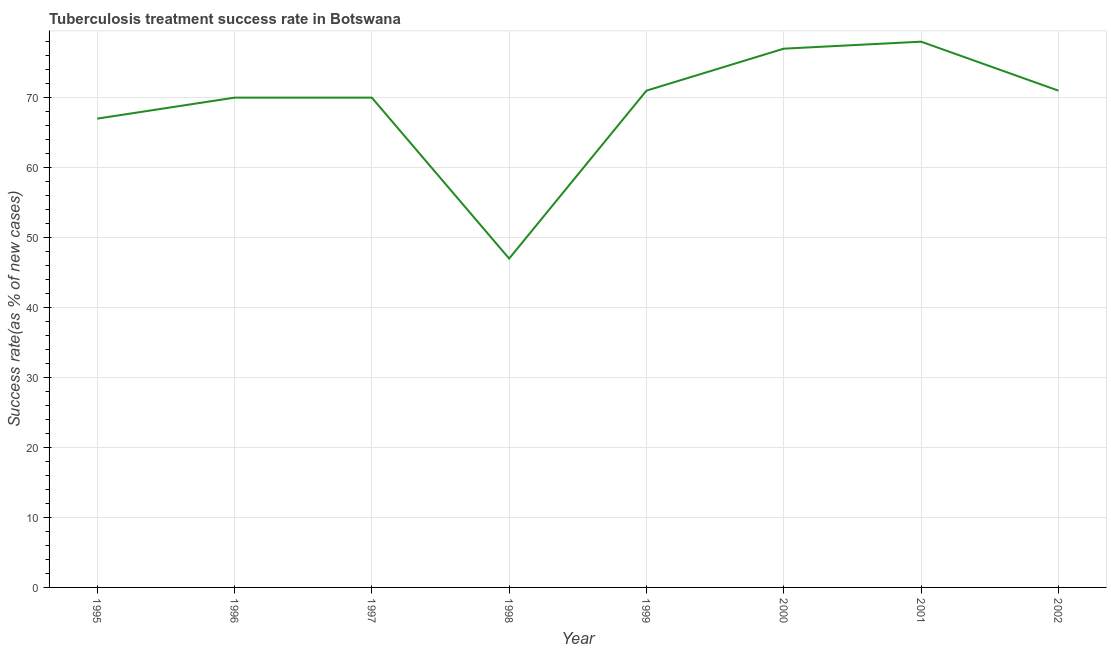What is the tuberculosis treatment success rate in 1997?
Your response must be concise. 70. Across all years, what is the maximum tuberculosis treatment success rate?
Provide a succinct answer. 78. Across all years, what is the minimum tuberculosis treatment success rate?
Make the answer very short. 47. In which year was the tuberculosis treatment success rate minimum?
Your answer should be compact. 1998. What is the sum of the tuberculosis treatment success rate?
Ensure brevity in your answer.  551. What is the difference between the tuberculosis treatment success rate in 1998 and 2000?
Keep it short and to the point. -30. What is the average tuberculosis treatment success rate per year?
Offer a terse response. 68.88. What is the median tuberculosis treatment success rate?
Offer a terse response. 70.5. In how many years, is the tuberculosis treatment success rate greater than 68 %?
Give a very brief answer. 6. What is the ratio of the tuberculosis treatment success rate in 1997 to that in 1998?
Your response must be concise. 1.49. Is the tuberculosis treatment success rate in 1999 less than that in 2001?
Give a very brief answer. Yes. What is the difference between the highest and the lowest tuberculosis treatment success rate?
Your answer should be very brief. 31. In how many years, is the tuberculosis treatment success rate greater than the average tuberculosis treatment success rate taken over all years?
Your response must be concise. 6. Does the tuberculosis treatment success rate monotonically increase over the years?
Offer a terse response. No. How many lines are there?
Offer a very short reply. 1. What is the difference between two consecutive major ticks on the Y-axis?
Keep it short and to the point. 10. Are the values on the major ticks of Y-axis written in scientific E-notation?
Your response must be concise. No. What is the title of the graph?
Your response must be concise. Tuberculosis treatment success rate in Botswana. What is the label or title of the Y-axis?
Ensure brevity in your answer.  Success rate(as % of new cases). What is the Success rate(as % of new cases) of 1995?
Make the answer very short. 67. What is the Success rate(as % of new cases) in 1996?
Give a very brief answer. 70. What is the Success rate(as % of new cases) of 1998?
Your answer should be compact. 47. What is the Success rate(as % of new cases) of 2000?
Your answer should be compact. 77. What is the Success rate(as % of new cases) in 2001?
Your response must be concise. 78. What is the Success rate(as % of new cases) of 2002?
Provide a succinct answer. 71. What is the difference between the Success rate(as % of new cases) in 1995 and 1996?
Provide a short and direct response. -3. What is the difference between the Success rate(as % of new cases) in 1995 and 1998?
Ensure brevity in your answer.  20. What is the difference between the Success rate(as % of new cases) in 1995 and 2001?
Provide a short and direct response. -11. What is the difference between the Success rate(as % of new cases) in 1996 and 1997?
Your response must be concise. 0. What is the difference between the Success rate(as % of new cases) in 1996 and 1998?
Give a very brief answer. 23. What is the difference between the Success rate(as % of new cases) in 1997 and 1998?
Your response must be concise. 23. What is the difference between the Success rate(as % of new cases) in 1997 and 2002?
Provide a short and direct response. -1. What is the difference between the Success rate(as % of new cases) in 1998 and 1999?
Your answer should be very brief. -24. What is the difference between the Success rate(as % of new cases) in 1998 and 2001?
Provide a short and direct response. -31. What is the difference between the Success rate(as % of new cases) in 2001 and 2002?
Make the answer very short. 7. What is the ratio of the Success rate(as % of new cases) in 1995 to that in 1996?
Offer a very short reply. 0.96. What is the ratio of the Success rate(as % of new cases) in 1995 to that in 1997?
Provide a short and direct response. 0.96. What is the ratio of the Success rate(as % of new cases) in 1995 to that in 1998?
Keep it short and to the point. 1.43. What is the ratio of the Success rate(as % of new cases) in 1995 to that in 1999?
Give a very brief answer. 0.94. What is the ratio of the Success rate(as % of new cases) in 1995 to that in 2000?
Your answer should be compact. 0.87. What is the ratio of the Success rate(as % of new cases) in 1995 to that in 2001?
Offer a terse response. 0.86. What is the ratio of the Success rate(as % of new cases) in 1995 to that in 2002?
Ensure brevity in your answer.  0.94. What is the ratio of the Success rate(as % of new cases) in 1996 to that in 1997?
Keep it short and to the point. 1. What is the ratio of the Success rate(as % of new cases) in 1996 to that in 1998?
Offer a very short reply. 1.49. What is the ratio of the Success rate(as % of new cases) in 1996 to that in 2000?
Give a very brief answer. 0.91. What is the ratio of the Success rate(as % of new cases) in 1996 to that in 2001?
Offer a very short reply. 0.9. What is the ratio of the Success rate(as % of new cases) in 1996 to that in 2002?
Your answer should be very brief. 0.99. What is the ratio of the Success rate(as % of new cases) in 1997 to that in 1998?
Your response must be concise. 1.49. What is the ratio of the Success rate(as % of new cases) in 1997 to that in 2000?
Your answer should be compact. 0.91. What is the ratio of the Success rate(as % of new cases) in 1997 to that in 2001?
Provide a short and direct response. 0.9. What is the ratio of the Success rate(as % of new cases) in 1998 to that in 1999?
Offer a very short reply. 0.66. What is the ratio of the Success rate(as % of new cases) in 1998 to that in 2000?
Keep it short and to the point. 0.61. What is the ratio of the Success rate(as % of new cases) in 1998 to that in 2001?
Your answer should be compact. 0.6. What is the ratio of the Success rate(as % of new cases) in 1998 to that in 2002?
Give a very brief answer. 0.66. What is the ratio of the Success rate(as % of new cases) in 1999 to that in 2000?
Your response must be concise. 0.92. What is the ratio of the Success rate(as % of new cases) in 1999 to that in 2001?
Make the answer very short. 0.91. What is the ratio of the Success rate(as % of new cases) in 1999 to that in 2002?
Provide a succinct answer. 1. What is the ratio of the Success rate(as % of new cases) in 2000 to that in 2001?
Ensure brevity in your answer.  0.99. What is the ratio of the Success rate(as % of new cases) in 2000 to that in 2002?
Your answer should be compact. 1.08. What is the ratio of the Success rate(as % of new cases) in 2001 to that in 2002?
Ensure brevity in your answer.  1.1. 